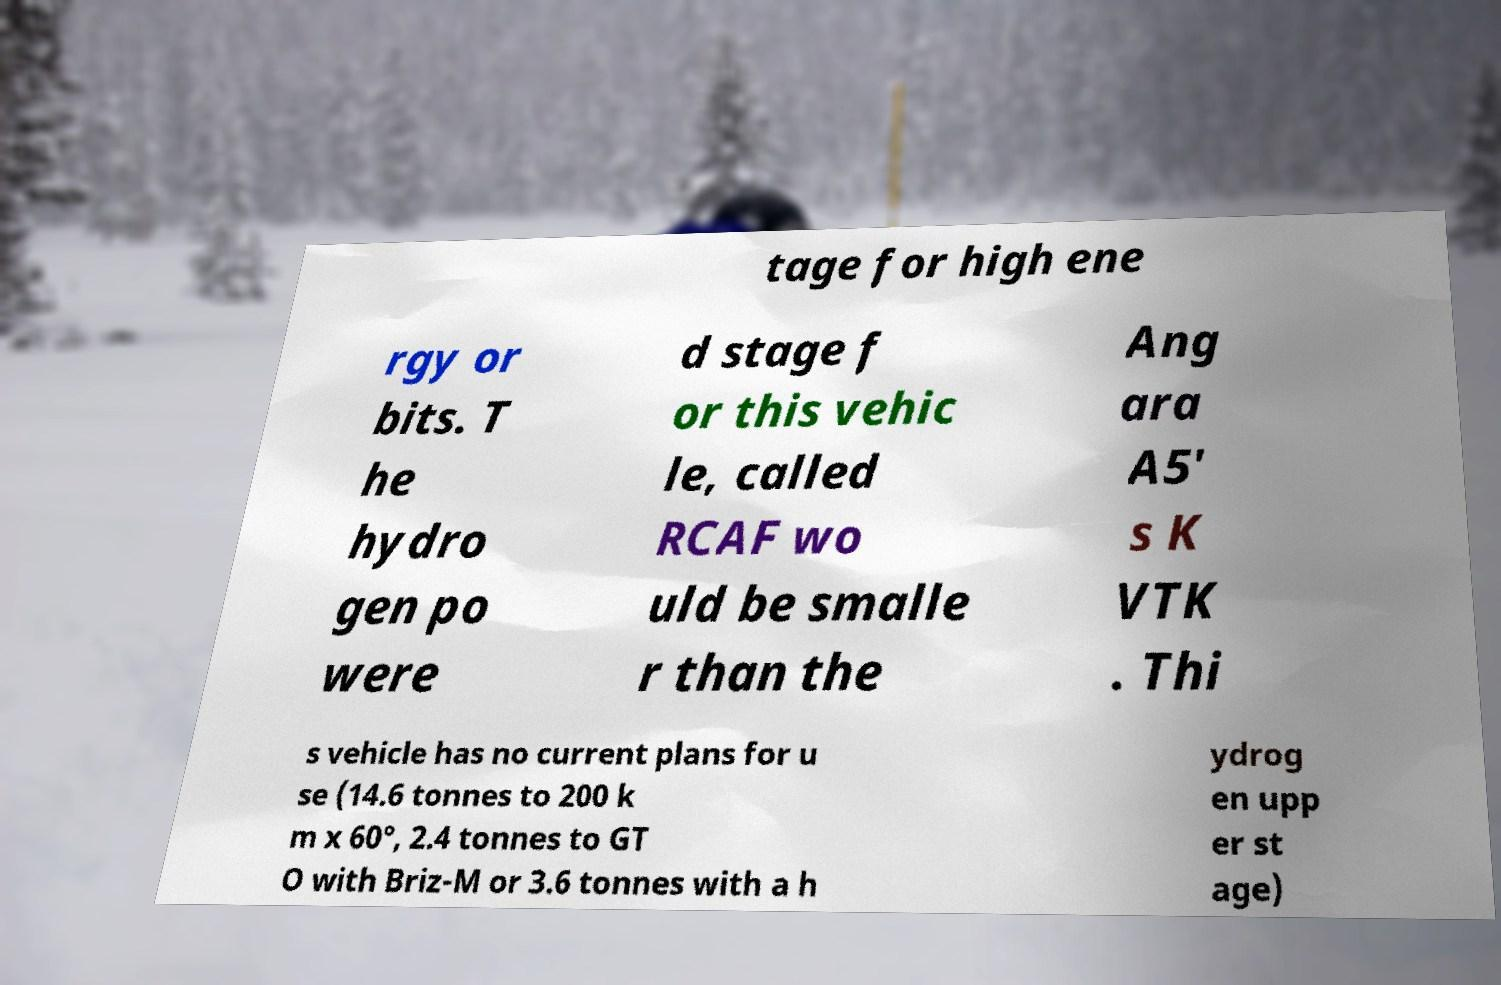Can you read and provide the text displayed in the image?This photo seems to have some interesting text. Can you extract and type it out for me? tage for high ene rgy or bits. T he hydro gen po were d stage f or this vehic le, called RCAF wo uld be smalle r than the Ang ara A5' s K VTK . Thi s vehicle has no current plans for u se (14.6 tonnes to 200 k m x 60°, 2.4 tonnes to GT O with Briz-M or 3.6 tonnes with a h ydrog en upp er st age) 